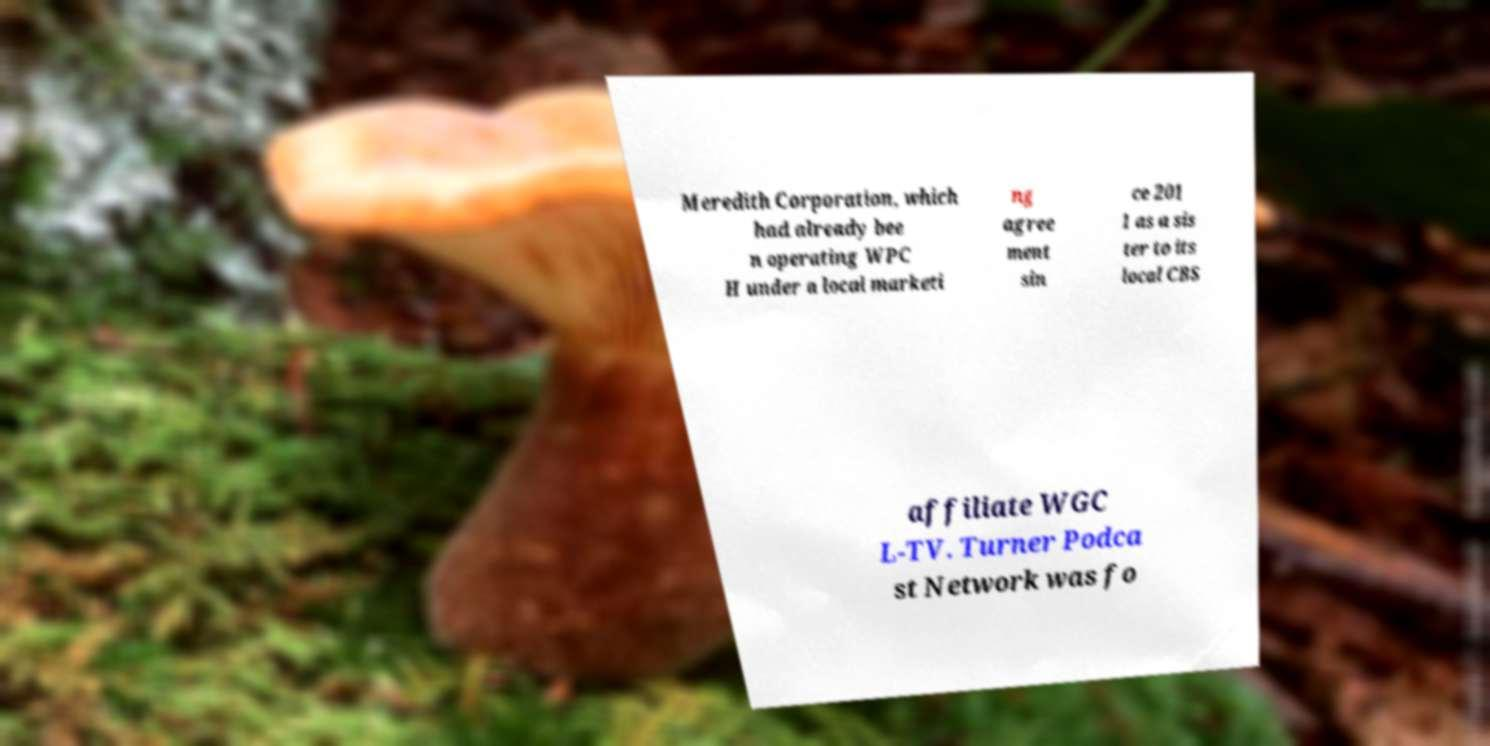There's text embedded in this image that I need extracted. Can you transcribe it verbatim? Meredith Corporation, which had already bee n operating WPC H under a local marketi ng agree ment sin ce 201 1 as a sis ter to its local CBS affiliate WGC L-TV. Turner Podca st Network was fo 